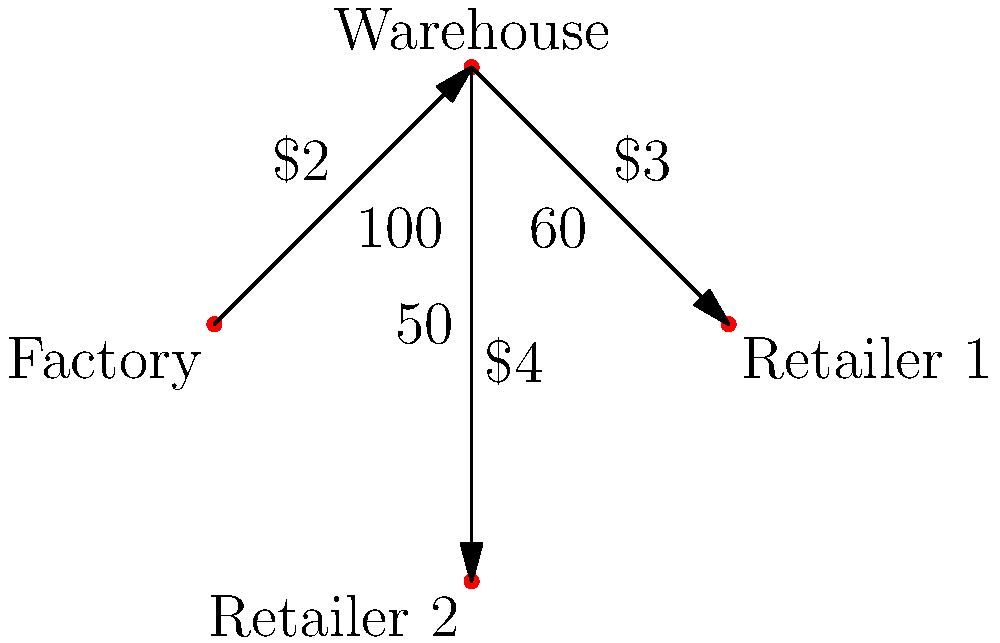Given the supply chain network diagram, what is the maximum profit achievable if the factory can produce up to 100 units, each unit sold to Retailer 1 generates $10 profit, and each unit sold to Retailer 2 generates $12 profit? To determine the maximum profit, we need to follow these steps:

1. Identify the bottleneck: The warehouse can only handle 100 units from the factory.

2. Analyze the paths to retailers:
   - Factory → Warehouse → Retailer 1: Capacity 60, Cost $2 + $3 = $5
   - Factory → Warehouse → Retailer 2: Capacity 50, Cost $2 + $4 = $6

3. Calculate profit per unit for each retailer:
   - Retailer 1: $10 - $5 = $5 profit per unit
   - Retailer 2: $12 - $6 = $6 profit per unit

4. Optimize distribution:
   - Retailer 2 is more profitable, so fill its capacity first: 50 units
   - Remaining capacity goes to Retailer 1: 50 units (limited by warehouse capacity)

5. Calculate total profit:
   - Profit from Retailer 1: 50 units × $5/unit = $250
   - Profit from Retailer 2: 50 units × $6/unit = $300
   - Total profit: $250 + $300 = $550

Therefore, the maximum achievable profit is $550.
Answer: $550 